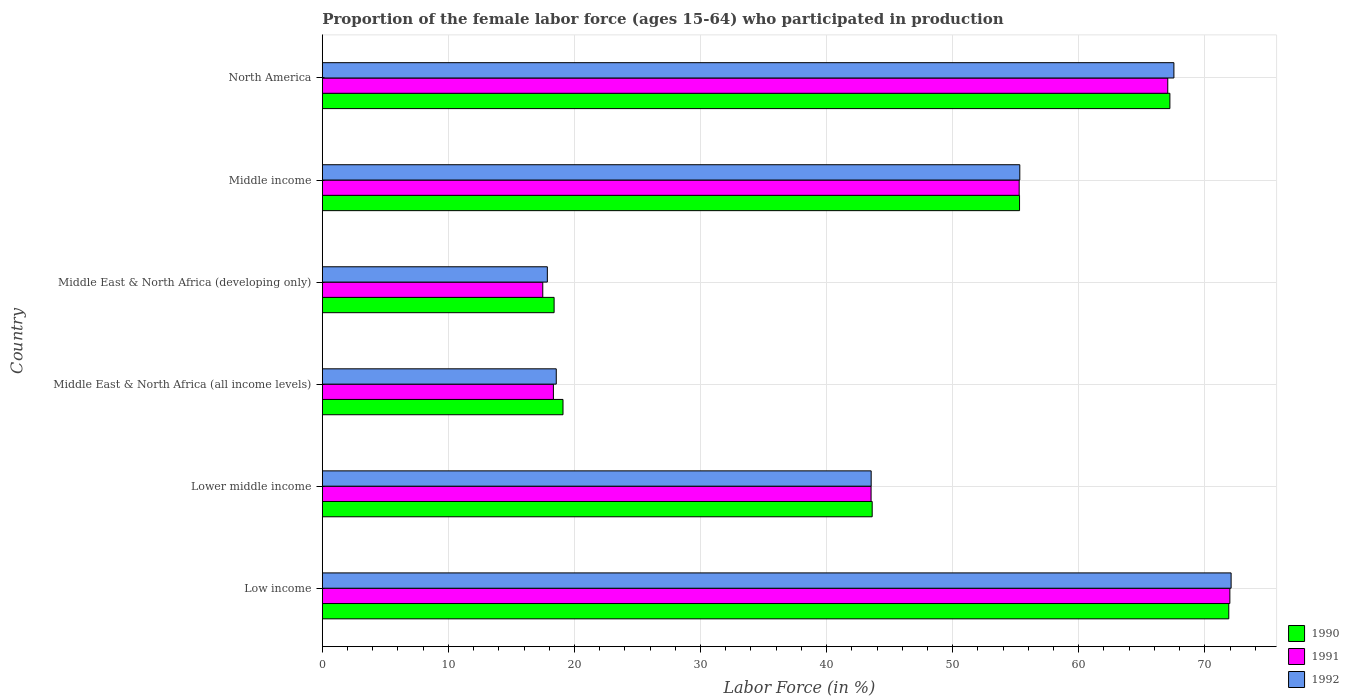Are the number of bars on each tick of the Y-axis equal?
Provide a succinct answer. Yes. What is the label of the 6th group of bars from the top?
Provide a short and direct response. Low income. What is the proportion of the female labor force who participated in production in 1992 in Middle income?
Give a very brief answer. 55.33. Across all countries, what is the maximum proportion of the female labor force who participated in production in 1991?
Provide a short and direct response. 71.99. Across all countries, what is the minimum proportion of the female labor force who participated in production in 1990?
Ensure brevity in your answer.  18.39. In which country was the proportion of the female labor force who participated in production in 1991 minimum?
Offer a terse response. Middle East & North Africa (developing only). What is the total proportion of the female labor force who participated in production in 1991 in the graph?
Your response must be concise. 273.68. What is the difference between the proportion of the female labor force who participated in production in 1992 in Lower middle income and that in Middle East & North Africa (developing only)?
Your answer should be compact. 25.69. What is the difference between the proportion of the female labor force who participated in production in 1991 in Middle income and the proportion of the female labor force who participated in production in 1992 in North America?
Your response must be concise. -12.27. What is the average proportion of the female labor force who participated in production in 1990 per country?
Your answer should be very brief. 45.92. What is the difference between the proportion of the female labor force who participated in production in 1991 and proportion of the female labor force who participated in production in 1992 in North America?
Your answer should be compact. -0.49. What is the ratio of the proportion of the female labor force who participated in production in 1991 in Middle East & North Africa (all income levels) to that in Middle income?
Provide a succinct answer. 0.33. What is the difference between the highest and the second highest proportion of the female labor force who participated in production in 1992?
Your response must be concise. 4.54. What is the difference between the highest and the lowest proportion of the female labor force who participated in production in 1990?
Provide a succinct answer. 53.52. In how many countries, is the proportion of the female labor force who participated in production in 1990 greater than the average proportion of the female labor force who participated in production in 1990 taken over all countries?
Give a very brief answer. 3. Is the sum of the proportion of the female labor force who participated in production in 1992 in Low income and Lower middle income greater than the maximum proportion of the female labor force who participated in production in 1990 across all countries?
Your answer should be compact. Yes. What does the 3rd bar from the top in Middle East & North Africa (developing only) represents?
Provide a short and direct response. 1990. What does the 3rd bar from the bottom in Middle income represents?
Provide a succinct answer. 1992. How many bars are there?
Keep it short and to the point. 18. Are all the bars in the graph horizontal?
Offer a terse response. Yes. How many countries are there in the graph?
Ensure brevity in your answer.  6. What is the difference between two consecutive major ticks on the X-axis?
Offer a terse response. 10. Does the graph contain any zero values?
Your answer should be very brief. No. Does the graph contain grids?
Provide a short and direct response. Yes. What is the title of the graph?
Keep it short and to the point. Proportion of the female labor force (ages 15-64) who participated in production. Does "1982" appear as one of the legend labels in the graph?
Offer a very short reply. No. What is the label or title of the Y-axis?
Your response must be concise. Country. What is the Labor Force (in %) of 1990 in Low income?
Your answer should be very brief. 71.9. What is the Labor Force (in %) in 1991 in Low income?
Offer a terse response. 71.99. What is the Labor Force (in %) of 1992 in Low income?
Keep it short and to the point. 72.09. What is the Labor Force (in %) of 1990 in Lower middle income?
Offer a terse response. 43.62. What is the Labor Force (in %) of 1991 in Lower middle income?
Give a very brief answer. 43.53. What is the Labor Force (in %) in 1992 in Lower middle income?
Give a very brief answer. 43.54. What is the Labor Force (in %) of 1990 in Middle East & North Africa (all income levels)?
Your answer should be very brief. 19.09. What is the Labor Force (in %) of 1991 in Middle East & North Africa (all income levels)?
Provide a short and direct response. 18.33. What is the Labor Force (in %) of 1992 in Middle East & North Africa (all income levels)?
Make the answer very short. 18.56. What is the Labor Force (in %) in 1990 in Middle East & North Africa (developing only)?
Provide a short and direct response. 18.39. What is the Labor Force (in %) of 1991 in Middle East & North Africa (developing only)?
Give a very brief answer. 17.49. What is the Labor Force (in %) in 1992 in Middle East & North Africa (developing only)?
Give a very brief answer. 17.85. What is the Labor Force (in %) in 1990 in Middle income?
Provide a succinct answer. 55.31. What is the Labor Force (in %) of 1991 in Middle income?
Keep it short and to the point. 55.28. What is the Labor Force (in %) of 1992 in Middle income?
Your response must be concise. 55.33. What is the Labor Force (in %) of 1990 in North America?
Your answer should be very brief. 67.23. What is the Labor Force (in %) of 1991 in North America?
Your answer should be very brief. 67.06. What is the Labor Force (in %) in 1992 in North America?
Offer a very short reply. 67.55. Across all countries, what is the maximum Labor Force (in %) of 1990?
Provide a short and direct response. 71.9. Across all countries, what is the maximum Labor Force (in %) in 1991?
Provide a short and direct response. 71.99. Across all countries, what is the maximum Labor Force (in %) of 1992?
Your response must be concise. 72.09. Across all countries, what is the minimum Labor Force (in %) in 1990?
Give a very brief answer. 18.39. Across all countries, what is the minimum Labor Force (in %) in 1991?
Offer a terse response. 17.49. Across all countries, what is the minimum Labor Force (in %) of 1992?
Make the answer very short. 17.85. What is the total Labor Force (in %) in 1990 in the graph?
Keep it short and to the point. 275.54. What is the total Labor Force (in %) in 1991 in the graph?
Your answer should be compact. 273.68. What is the total Labor Force (in %) in 1992 in the graph?
Your answer should be very brief. 274.91. What is the difference between the Labor Force (in %) of 1990 in Low income and that in Lower middle income?
Keep it short and to the point. 28.29. What is the difference between the Labor Force (in %) of 1991 in Low income and that in Lower middle income?
Ensure brevity in your answer.  28.46. What is the difference between the Labor Force (in %) in 1992 in Low income and that in Lower middle income?
Provide a short and direct response. 28.55. What is the difference between the Labor Force (in %) of 1990 in Low income and that in Middle East & North Africa (all income levels)?
Ensure brevity in your answer.  52.81. What is the difference between the Labor Force (in %) in 1991 in Low income and that in Middle East & North Africa (all income levels)?
Provide a succinct answer. 53.66. What is the difference between the Labor Force (in %) in 1992 in Low income and that in Middle East & North Africa (all income levels)?
Make the answer very short. 53.53. What is the difference between the Labor Force (in %) of 1990 in Low income and that in Middle East & North Africa (developing only)?
Your response must be concise. 53.52. What is the difference between the Labor Force (in %) in 1991 in Low income and that in Middle East & North Africa (developing only)?
Give a very brief answer. 54.5. What is the difference between the Labor Force (in %) of 1992 in Low income and that in Middle East & North Africa (developing only)?
Your response must be concise. 54.24. What is the difference between the Labor Force (in %) of 1990 in Low income and that in Middle income?
Offer a very short reply. 16.6. What is the difference between the Labor Force (in %) in 1991 in Low income and that in Middle income?
Keep it short and to the point. 16.71. What is the difference between the Labor Force (in %) of 1992 in Low income and that in Middle income?
Ensure brevity in your answer.  16.76. What is the difference between the Labor Force (in %) in 1990 in Low income and that in North America?
Your response must be concise. 4.67. What is the difference between the Labor Force (in %) in 1991 in Low income and that in North America?
Offer a terse response. 4.93. What is the difference between the Labor Force (in %) in 1992 in Low income and that in North America?
Your answer should be compact. 4.54. What is the difference between the Labor Force (in %) in 1990 in Lower middle income and that in Middle East & North Africa (all income levels)?
Keep it short and to the point. 24.53. What is the difference between the Labor Force (in %) in 1991 in Lower middle income and that in Middle East & North Africa (all income levels)?
Provide a succinct answer. 25.2. What is the difference between the Labor Force (in %) of 1992 in Lower middle income and that in Middle East & North Africa (all income levels)?
Offer a terse response. 24.98. What is the difference between the Labor Force (in %) of 1990 in Lower middle income and that in Middle East & North Africa (developing only)?
Provide a succinct answer. 25.23. What is the difference between the Labor Force (in %) in 1991 in Lower middle income and that in Middle East & North Africa (developing only)?
Provide a succinct answer. 26.04. What is the difference between the Labor Force (in %) of 1992 in Lower middle income and that in Middle East & North Africa (developing only)?
Provide a succinct answer. 25.69. What is the difference between the Labor Force (in %) in 1990 in Lower middle income and that in Middle income?
Ensure brevity in your answer.  -11.69. What is the difference between the Labor Force (in %) in 1991 in Lower middle income and that in Middle income?
Give a very brief answer. -11.75. What is the difference between the Labor Force (in %) in 1992 in Lower middle income and that in Middle income?
Your answer should be compact. -11.79. What is the difference between the Labor Force (in %) of 1990 in Lower middle income and that in North America?
Provide a succinct answer. -23.62. What is the difference between the Labor Force (in %) of 1991 in Lower middle income and that in North America?
Give a very brief answer. -23.53. What is the difference between the Labor Force (in %) in 1992 in Lower middle income and that in North America?
Offer a very short reply. -24.01. What is the difference between the Labor Force (in %) in 1990 in Middle East & North Africa (all income levels) and that in Middle East & North Africa (developing only)?
Your answer should be compact. 0.7. What is the difference between the Labor Force (in %) in 1991 in Middle East & North Africa (all income levels) and that in Middle East & North Africa (developing only)?
Offer a terse response. 0.84. What is the difference between the Labor Force (in %) of 1992 in Middle East & North Africa (all income levels) and that in Middle East & North Africa (developing only)?
Your response must be concise. 0.71. What is the difference between the Labor Force (in %) in 1990 in Middle East & North Africa (all income levels) and that in Middle income?
Provide a succinct answer. -36.21. What is the difference between the Labor Force (in %) in 1991 in Middle East & North Africa (all income levels) and that in Middle income?
Your response must be concise. -36.95. What is the difference between the Labor Force (in %) in 1992 in Middle East & North Africa (all income levels) and that in Middle income?
Provide a short and direct response. -36.77. What is the difference between the Labor Force (in %) in 1990 in Middle East & North Africa (all income levels) and that in North America?
Provide a succinct answer. -48.14. What is the difference between the Labor Force (in %) of 1991 in Middle East & North Africa (all income levels) and that in North America?
Keep it short and to the point. -48.73. What is the difference between the Labor Force (in %) of 1992 in Middle East & North Africa (all income levels) and that in North America?
Keep it short and to the point. -48.99. What is the difference between the Labor Force (in %) of 1990 in Middle East & North Africa (developing only) and that in Middle income?
Keep it short and to the point. -36.92. What is the difference between the Labor Force (in %) of 1991 in Middle East & North Africa (developing only) and that in Middle income?
Ensure brevity in your answer.  -37.79. What is the difference between the Labor Force (in %) in 1992 in Middle East & North Africa (developing only) and that in Middle income?
Offer a terse response. -37.48. What is the difference between the Labor Force (in %) of 1990 in Middle East & North Africa (developing only) and that in North America?
Your answer should be very brief. -48.85. What is the difference between the Labor Force (in %) of 1991 in Middle East & North Africa (developing only) and that in North America?
Your response must be concise. -49.58. What is the difference between the Labor Force (in %) in 1992 in Middle East & North Africa (developing only) and that in North America?
Keep it short and to the point. -49.7. What is the difference between the Labor Force (in %) in 1990 in Middle income and that in North America?
Your response must be concise. -11.93. What is the difference between the Labor Force (in %) of 1991 in Middle income and that in North America?
Provide a short and direct response. -11.79. What is the difference between the Labor Force (in %) in 1992 in Middle income and that in North America?
Provide a short and direct response. -12.23. What is the difference between the Labor Force (in %) in 1990 in Low income and the Labor Force (in %) in 1991 in Lower middle income?
Give a very brief answer. 28.37. What is the difference between the Labor Force (in %) of 1990 in Low income and the Labor Force (in %) of 1992 in Lower middle income?
Offer a terse response. 28.37. What is the difference between the Labor Force (in %) in 1991 in Low income and the Labor Force (in %) in 1992 in Lower middle income?
Your answer should be compact. 28.45. What is the difference between the Labor Force (in %) in 1990 in Low income and the Labor Force (in %) in 1991 in Middle East & North Africa (all income levels)?
Make the answer very short. 53.57. What is the difference between the Labor Force (in %) of 1990 in Low income and the Labor Force (in %) of 1992 in Middle East & North Africa (all income levels)?
Offer a terse response. 53.35. What is the difference between the Labor Force (in %) of 1991 in Low income and the Labor Force (in %) of 1992 in Middle East & North Africa (all income levels)?
Provide a succinct answer. 53.43. What is the difference between the Labor Force (in %) in 1990 in Low income and the Labor Force (in %) in 1991 in Middle East & North Africa (developing only)?
Keep it short and to the point. 54.42. What is the difference between the Labor Force (in %) of 1990 in Low income and the Labor Force (in %) of 1992 in Middle East & North Africa (developing only)?
Your response must be concise. 54.05. What is the difference between the Labor Force (in %) of 1991 in Low income and the Labor Force (in %) of 1992 in Middle East & North Africa (developing only)?
Your answer should be very brief. 54.14. What is the difference between the Labor Force (in %) of 1990 in Low income and the Labor Force (in %) of 1991 in Middle income?
Provide a short and direct response. 16.63. What is the difference between the Labor Force (in %) in 1990 in Low income and the Labor Force (in %) in 1992 in Middle income?
Keep it short and to the point. 16.58. What is the difference between the Labor Force (in %) in 1991 in Low income and the Labor Force (in %) in 1992 in Middle income?
Make the answer very short. 16.66. What is the difference between the Labor Force (in %) of 1990 in Low income and the Labor Force (in %) of 1991 in North America?
Offer a terse response. 4.84. What is the difference between the Labor Force (in %) in 1990 in Low income and the Labor Force (in %) in 1992 in North America?
Offer a very short reply. 4.35. What is the difference between the Labor Force (in %) in 1991 in Low income and the Labor Force (in %) in 1992 in North America?
Give a very brief answer. 4.44. What is the difference between the Labor Force (in %) of 1990 in Lower middle income and the Labor Force (in %) of 1991 in Middle East & North Africa (all income levels)?
Make the answer very short. 25.29. What is the difference between the Labor Force (in %) of 1990 in Lower middle income and the Labor Force (in %) of 1992 in Middle East & North Africa (all income levels)?
Your answer should be very brief. 25.06. What is the difference between the Labor Force (in %) in 1991 in Lower middle income and the Labor Force (in %) in 1992 in Middle East & North Africa (all income levels)?
Your response must be concise. 24.97. What is the difference between the Labor Force (in %) of 1990 in Lower middle income and the Labor Force (in %) of 1991 in Middle East & North Africa (developing only)?
Make the answer very short. 26.13. What is the difference between the Labor Force (in %) in 1990 in Lower middle income and the Labor Force (in %) in 1992 in Middle East & North Africa (developing only)?
Your response must be concise. 25.77. What is the difference between the Labor Force (in %) in 1991 in Lower middle income and the Labor Force (in %) in 1992 in Middle East & North Africa (developing only)?
Your answer should be compact. 25.68. What is the difference between the Labor Force (in %) of 1990 in Lower middle income and the Labor Force (in %) of 1991 in Middle income?
Ensure brevity in your answer.  -11.66. What is the difference between the Labor Force (in %) of 1990 in Lower middle income and the Labor Force (in %) of 1992 in Middle income?
Provide a short and direct response. -11.71. What is the difference between the Labor Force (in %) of 1991 in Lower middle income and the Labor Force (in %) of 1992 in Middle income?
Your answer should be very brief. -11.8. What is the difference between the Labor Force (in %) in 1990 in Lower middle income and the Labor Force (in %) in 1991 in North America?
Keep it short and to the point. -23.45. What is the difference between the Labor Force (in %) of 1990 in Lower middle income and the Labor Force (in %) of 1992 in North America?
Give a very brief answer. -23.93. What is the difference between the Labor Force (in %) of 1991 in Lower middle income and the Labor Force (in %) of 1992 in North America?
Keep it short and to the point. -24.02. What is the difference between the Labor Force (in %) in 1990 in Middle East & North Africa (all income levels) and the Labor Force (in %) in 1991 in Middle East & North Africa (developing only)?
Make the answer very short. 1.6. What is the difference between the Labor Force (in %) of 1990 in Middle East & North Africa (all income levels) and the Labor Force (in %) of 1992 in Middle East & North Africa (developing only)?
Make the answer very short. 1.24. What is the difference between the Labor Force (in %) in 1991 in Middle East & North Africa (all income levels) and the Labor Force (in %) in 1992 in Middle East & North Africa (developing only)?
Your response must be concise. 0.48. What is the difference between the Labor Force (in %) in 1990 in Middle East & North Africa (all income levels) and the Labor Force (in %) in 1991 in Middle income?
Offer a terse response. -36.19. What is the difference between the Labor Force (in %) in 1990 in Middle East & North Africa (all income levels) and the Labor Force (in %) in 1992 in Middle income?
Offer a terse response. -36.23. What is the difference between the Labor Force (in %) in 1991 in Middle East & North Africa (all income levels) and the Labor Force (in %) in 1992 in Middle income?
Your response must be concise. -37. What is the difference between the Labor Force (in %) of 1990 in Middle East & North Africa (all income levels) and the Labor Force (in %) of 1991 in North America?
Offer a terse response. -47.97. What is the difference between the Labor Force (in %) in 1990 in Middle East & North Africa (all income levels) and the Labor Force (in %) in 1992 in North America?
Your answer should be very brief. -48.46. What is the difference between the Labor Force (in %) in 1991 in Middle East & North Africa (all income levels) and the Labor Force (in %) in 1992 in North America?
Give a very brief answer. -49.22. What is the difference between the Labor Force (in %) in 1990 in Middle East & North Africa (developing only) and the Labor Force (in %) in 1991 in Middle income?
Provide a succinct answer. -36.89. What is the difference between the Labor Force (in %) in 1990 in Middle East & North Africa (developing only) and the Labor Force (in %) in 1992 in Middle income?
Your answer should be very brief. -36.94. What is the difference between the Labor Force (in %) in 1991 in Middle East & North Africa (developing only) and the Labor Force (in %) in 1992 in Middle income?
Ensure brevity in your answer.  -37.84. What is the difference between the Labor Force (in %) in 1990 in Middle East & North Africa (developing only) and the Labor Force (in %) in 1991 in North America?
Make the answer very short. -48.68. What is the difference between the Labor Force (in %) of 1990 in Middle East & North Africa (developing only) and the Labor Force (in %) of 1992 in North America?
Provide a succinct answer. -49.16. What is the difference between the Labor Force (in %) of 1991 in Middle East & North Africa (developing only) and the Labor Force (in %) of 1992 in North America?
Your answer should be very brief. -50.06. What is the difference between the Labor Force (in %) of 1990 in Middle income and the Labor Force (in %) of 1991 in North America?
Give a very brief answer. -11.76. What is the difference between the Labor Force (in %) in 1990 in Middle income and the Labor Force (in %) in 1992 in North America?
Offer a very short reply. -12.25. What is the difference between the Labor Force (in %) in 1991 in Middle income and the Labor Force (in %) in 1992 in North America?
Your response must be concise. -12.27. What is the average Labor Force (in %) in 1990 per country?
Your answer should be compact. 45.92. What is the average Labor Force (in %) of 1991 per country?
Offer a very short reply. 45.61. What is the average Labor Force (in %) of 1992 per country?
Give a very brief answer. 45.82. What is the difference between the Labor Force (in %) in 1990 and Labor Force (in %) in 1991 in Low income?
Give a very brief answer. -0.09. What is the difference between the Labor Force (in %) in 1990 and Labor Force (in %) in 1992 in Low income?
Give a very brief answer. -0.18. What is the difference between the Labor Force (in %) in 1991 and Labor Force (in %) in 1992 in Low income?
Provide a short and direct response. -0.1. What is the difference between the Labor Force (in %) of 1990 and Labor Force (in %) of 1991 in Lower middle income?
Keep it short and to the point. 0.09. What is the difference between the Labor Force (in %) in 1991 and Labor Force (in %) in 1992 in Lower middle income?
Offer a terse response. -0.01. What is the difference between the Labor Force (in %) in 1990 and Labor Force (in %) in 1991 in Middle East & North Africa (all income levels)?
Provide a succinct answer. 0.76. What is the difference between the Labor Force (in %) of 1990 and Labor Force (in %) of 1992 in Middle East & North Africa (all income levels)?
Your answer should be very brief. 0.53. What is the difference between the Labor Force (in %) of 1991 and Labor Force (in %) of 1992 in Middle East & North Africa (all income levels)?
Offer a terse response. -0.23. What is the difference between the Labor Force (in %) in 1990 and Labor Force (in %) in 1991 in Middle East & North Africa (developing only)?
Ensure brevity in your answer.  0.9. What is the difference between the Labor Force (in %) of 1990 and Labor Force (in %) of 1992 in Middle East & North Africa (developing only)?
Make the answer very short. 0.54. What is the difference between the Labor Force (in %) of 1991 and Labor Force (in %) of 1992 in Middle East & North Africa (developing only)?
Offer a very short reply. -0.36. What is the difference between the Labor Force (in %) of 1990 and Labor Force (in %) of 1991 in Middle income?
Offer a terse response. 0.03. What is the difference between the Labor Force (in %) in 1990 and Labor Force (in %) in 1992 in Middle income?
Keep it short and to the point. -0.02. What is the difference between the Labor Force (in %) of 1991 and Labor Force (in %) of 1992 in Middle income?
Offer a very short reply. -0.05. What is the difference between the Labor Force (in %) of 1990 and Labor Force (in %) of 1991 in North America?
Make the answer very short. 0.17. What is the difference between the Labor Force (in %) of 1990 and Labor Force (in %) of 1992 in North America?
Offer a very short reply. -0.32. What is the difference between the Labor Force (in %) of 1991 and Labor Force (in %) of 1992 in North America?
Offer a very short reply. -0.49. What is the ratio of the Labor Force (in %) in 1990 in Low income to that in Lower middle income?
Your answer should be compact. 1.65. What is the ratio of the Labor Force (in %) of 1991 in Low income to that in Lower middle income?
Give a very brief answer. 1.65. What is the ratio of the Labor Force (in %) in 1992 in Low income to that in Lower middle income?
Ensure brevity in your answer.  1.66. What is the ratio of the Labor Force (in %) in 1990 in Low income to that in Middle East & North Africa (all income levels)?
Your response must be concise. 3.77. What is the ratio of the Labor Force (in %) in 1991 in Low income to that in Middle East & North Africa (all income levels)?
Offer a very short reply. 3.93. What is the ratio of the Labor Force (in %) of 1992 in Low income to that in Middle East & North Africa (all income levels)?
Keep it short and to the point. 3.88. What is the ratio of the Labor Force (in %) of 1990 in Low income to that in Middle East & North Africa (developing only)?
Keep it short and to the point. 3.91. What is the ratio of the Labor Force (in %) of 1991 in Low income to that in Middle East & North Africa (developing only)?
Your response must be concise. 4.12. What is the ratio of the Labor Force (in %) in 1992 in Low income to that in Middle East & North Africa (developing only)?
Keep it short and to the point. 4.04. What is the ratio of the Labor Force (in %) of 1990 in Low income to that in Middle income?
Keep it short and to the point. 1.3. What is the ratio of the Labor Force (in %) in 1991 in Low income to that in Middle income?
Your response must be concise. 1.3. What is the ratio of the Labor Force (in %) of 1992 in Low income to that in Middle income?
Your answer should be compact. 1.3. What is the ratio of the Labor Force (in %) of 1990 in Low income to that in North America?
Make the answer very short. 1.07. What is the ratio of the Labor Force (in %) of 1991 in Low income to that in North America?
Give a very brief answer. 1.07. What is the ratio of the Labor Force (in %) of 1992 in Low income to that in North America?
Your response must be concise. 1.07. What is the ratio of the Labor Force (in %) of 1990 in Lower middle income to that in Middle East & North Africa (all income levels)?
Offer a terse response. 2.28. What is the ratio of the Labor Force (in %) in 1991 in Lower middle income to that in Middle East & North Africa (all income levels)?
Offer a very short reply. 2.37. What is the ratio of the Labor Force (in %) in 1992 in Lower middle income to that in Middle East & North Africa (all income levels)?
Ensure brevity in your answer.  2.35. What is the ratio of the Labor Force (in %) of 1990 in Lower middle income to that in Middle East & North Africa (developing only)?
Your answer should be compact. 2.37. What is the ratio of the Labor Force (in %) of 1991 in Lower middle income to that in Middle East & North Africa (developing only)?
Your answer should be compact. 2.49. What is the ratio of the Labor Force (in %) in 1992 in Lower middle income to that in Middle East & North Africa (developing only)?
Provide a short and direct response. 2.44. What is the ratio of the Labor Force (in %) in 1990 in Lower middle income to that in Middle income?
Your response must be concise. 0.79. What is the ratio of the Labor Force (in %) of 1991 in Lower middle income to that in Middle income?
Offer a terse response. 0.79. What is the ratio of the Labor Force (in %) of 1992 in Lower middle income to that in Middle income?
Provide a short and direct response. 0.79. What is the ratio of the Labor Force (in %) of 1990 in Lower middle income to that in North America?
Keep it short and to the point. 0.65. What is the ratio of the Labor Force (in %) of 1991 in Lower middle income to that in North America?
Keep it short and to the point. 0.65. What is the ratio of the Labor Force (in %) in 1992 in Lower middle income to that in North America?
Your answer should be very brief. 0.64. What is the ratio of the Labor Force (in %) in 1990 in Middle East & North Africa (all income levels) to that in Middle East & North Africa (developing only)?
Keep it short and to the point. 1.04. What is the ratio of the Labor Force (in %) of 1991 in Middle East & North Africa (all income levels) to that in Middle East & North Africa (developing only)?
Make the answer very short. 1.05. What is the ratio of the Labor Force (in %) in 1992 in Middle East & North Africa (all income levels) to that in Middle East & North Africa (developing only)?
Offer a very short reply. 1.04. What is the ratio of the Labor Force (in %) of 1990 in Middle East & North Africa (all income levels) to that in Middle income?
Provide a succinct answer. 0.35. What is the ratio of the Labor Force (in %) of 1991 in Middle East & North Africa (all income levels) to that in Middle income?
Offer a very short reply. 0.33. What is the ratio of the Labor Force (in %) of 1992 in Middle East & North Africa (all income levels) to that in Middle income?
Give a very brief answer. 0.34. What is the ratio of the Labor Force (in %) in 1990 in Middle East & North Africa (all income levels) to that in North America?
Offer a very short reply. 0.28. What is the ratio of the Labor Force (in %) in 1991 in Middle East & North Africa (all income levels) to that in North America?
Your response must be concise. 0.27. What is the ratio of the Labor Force (in %) of 1992 in Middle East & North Africa (all income levels) to that in North America?
Make the answer very short. 0.27. What is the ratio of the Labor Force (in %) of 1990 in Middle East & North Africa (developing only) to that in Middle income?
Keep it short and to the point. 0.33. What is the ratio of the Labor Force (in %) in 1991 in Middle East & North Africa (developing only) to that in Middle income?
Your response must be concise. 0.32. What is the ratio of the Labor Force (in %) in 1992 in Middle East & North Africa (developing only) to that in Middle income?
Your answer should be compact. 0.32. What is the ratio of the Labor Force (in %) in 1990 in Middle East & North Africa (developing only) to that in North America?
Your answer should be very brief. 0.27. What is the ratio of the Labor Force (in %) in 1991 in Middle East & North Africa (developing only) to that in North America?
Give a very brief answer. 0.26. What is the ratio of the Labor Force (in %) of 1992 in Middle East & North Africa (developing only) to that in North America?
Provide a succinct answer. 0.26. What is the ratio of the Labor Force (in %) in 1990 in Middle income to that in North America?
Offer a terse response. 0.82. What is the ratio of the Labor Force (in %) of 1991 in Middle income to that in North America?
Make the answer very short. 0.82. What is the ratio of the Labor Force (in %) in 1992 in Middle income to that in North America?
Your answer should be very brief. 0.82. What is the difference between the highest and the second highest Labor Force (in %) in 1990?
Offer a very short reply. 4.67. What is the difference between the highest and the second highest Labor Force (in %) in 1991?
Provide a succinct answer. 4.93. What is the difference between the highest and the second highest Labor Force (in %) of 1992?
Offer a very short reply. 4.54. What is the difference between the highest and the lowest Labor Force (in %) in 1990?
Your response must be concise. 53.52. What is the difference between the highest and the lowest Labor Force (in %) of 1991?
Offer a very short reply. 54.5. What is the difference between the highest and the lowest Labor Force (in %) of 1992?
Your answer should be very brief. 54.24. 